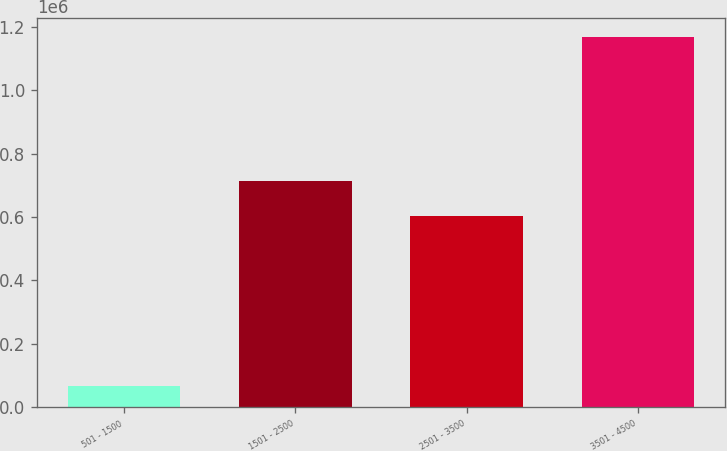Convert chart. <chart><loc_0><loc_0><loc_500><loc_500><bar_chart><fcel>501 - 1500<fcel>1501 - 2500<fcel>2501 - 3500<fcel>3501 - 4500<nl><fcel>68653<fcel>712410<fcel>602560<fcel>1.16715e+06<nl></chart> 